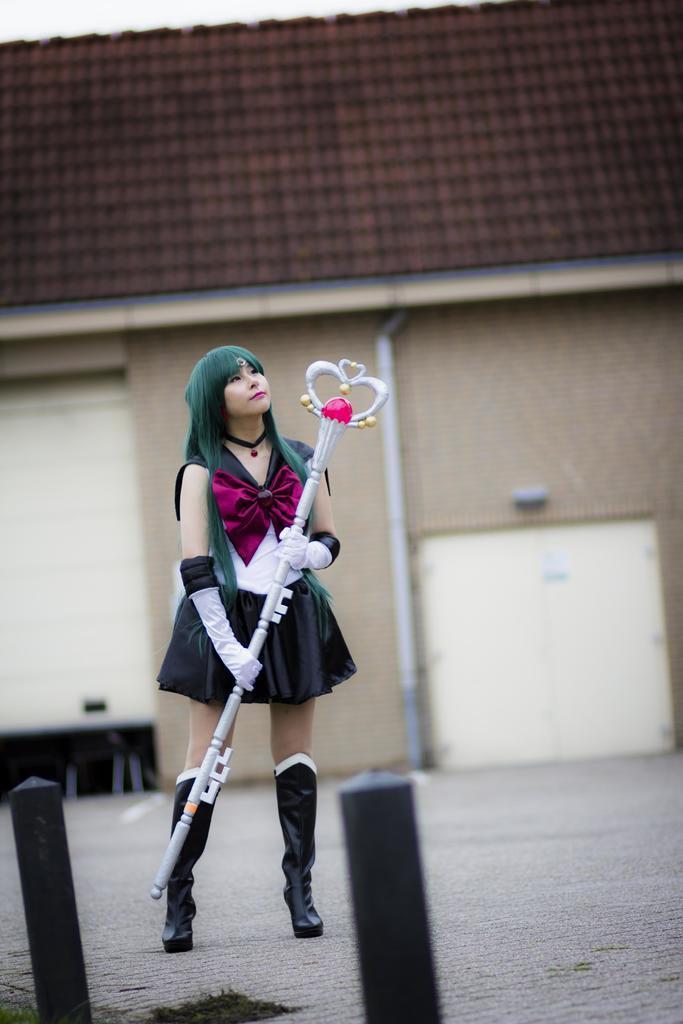In one or two sentences, can you explain what this image depicts? In this image we can see a woman wearing costume holding a stick in her hand is standing on the ground. In the foreground we can see poles. In the background, we can see a building with roof, doors and a pipe. 